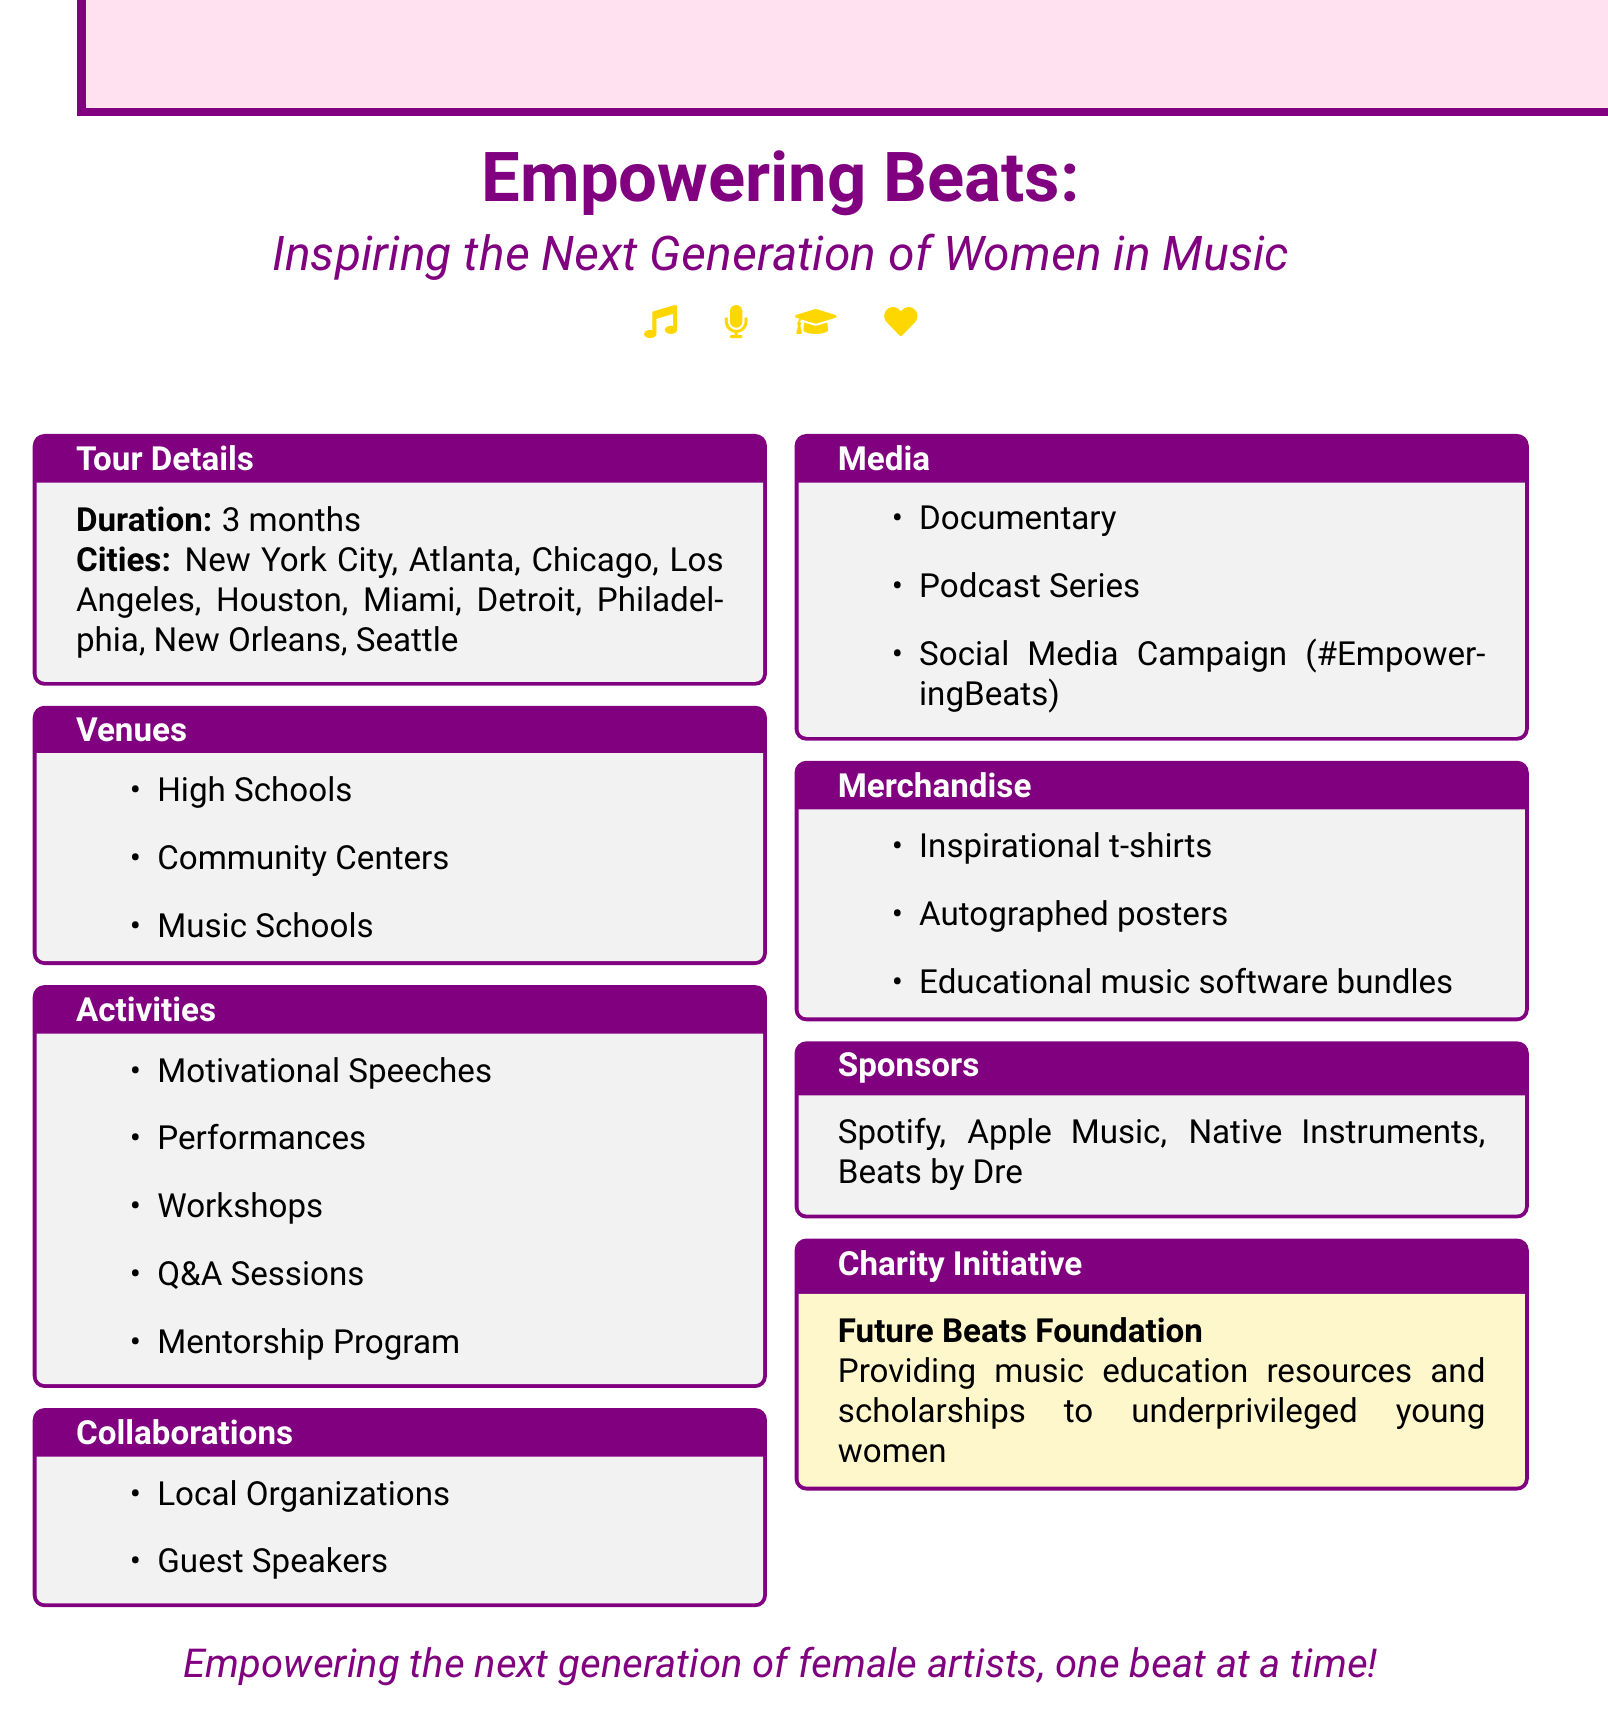What is the name of the tour? The name of the tour is explicitly mentioned in the document as "Empowering Beats: Inspiring the Next Generation of Women in Music."
Answer: Empowering Beats: Inspiring the Next Generation of Women in Music How long will the tour last? The document states that the duration of the tour is 3 months.
Answer: 3 months Which city is NOT listed in the tour schedule? By analyzing the list of cities, one can identify cities that are not included in the document. For example, San Francisco is not mentioned.
Answer: San Francisco What is one of the topics for motivational speeches? The document lists various topics for motivational speeches, one of which is "Breaking barriers in the hip-hop industry."
Answer: Breaking barriers in the hip-hop industry How many types of venues are mentioned? The document outlines three types of venues where the tour will take place.
Answer: 3 Which charity initiative is associated with the tour? The document specifies the charity initiative as "Future Beats Foundation."
Answer: Future Beats Foundation Name a local organization collaborating on this tour. The document lists several collaborations, including "Girls Make Beats."
Answer: Girls Make Beats What social media campaign hashtag is mentioned? The document highlights the hashtag for the social media campaign, which is "#EmpoweringBeats."
Answer: #EmpoweringBeats Who is one of the guest speakers? The document names several guest speakers, one of which is "Missy Elliott."
Answer: Missy Elliott 